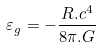Convert formula to latex. <formula><loc_0><loc_0><loc_500><loc_500>\varepsilon _ { g } = - \frac { { R . c ^ { 4 } } } { 8 \pi . G }</formula> 